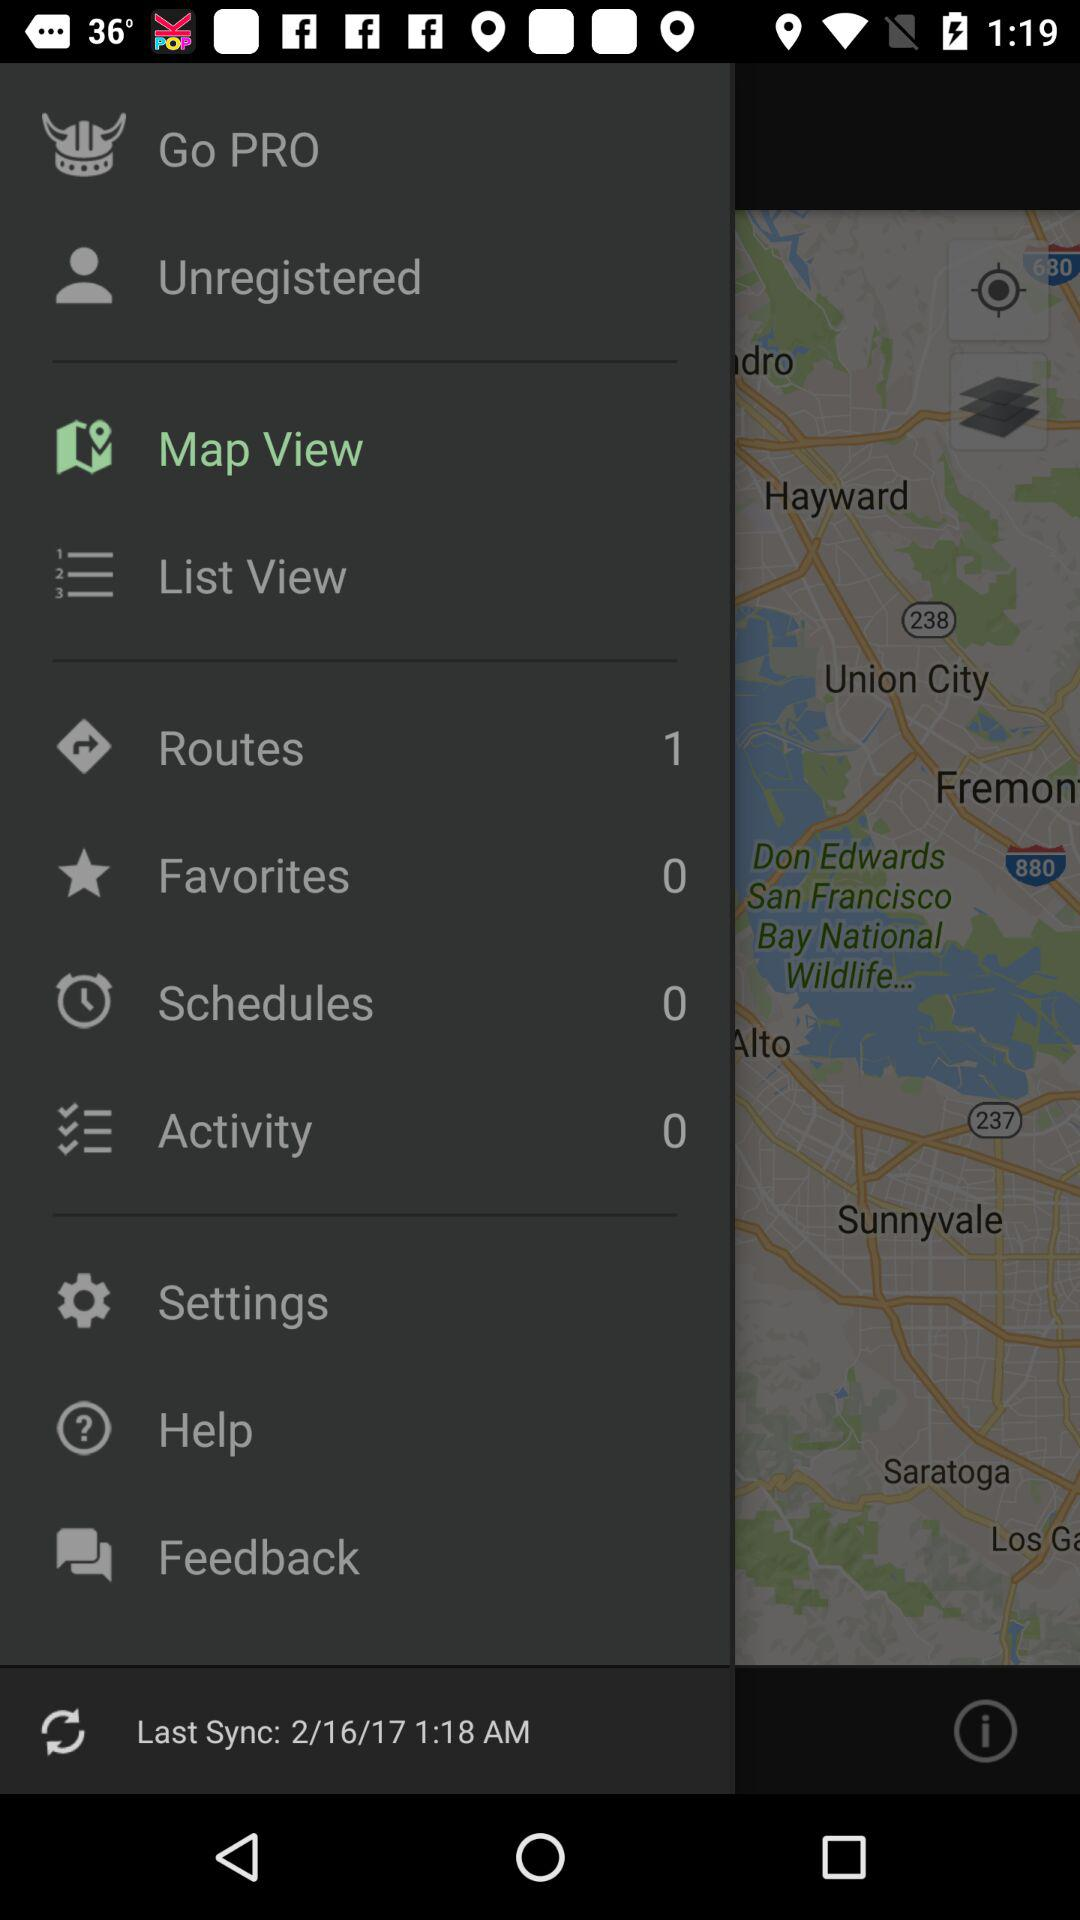What is the date and time of the last sync? The date and time are February 16, 2017 and 1:18 AM, respectively. 